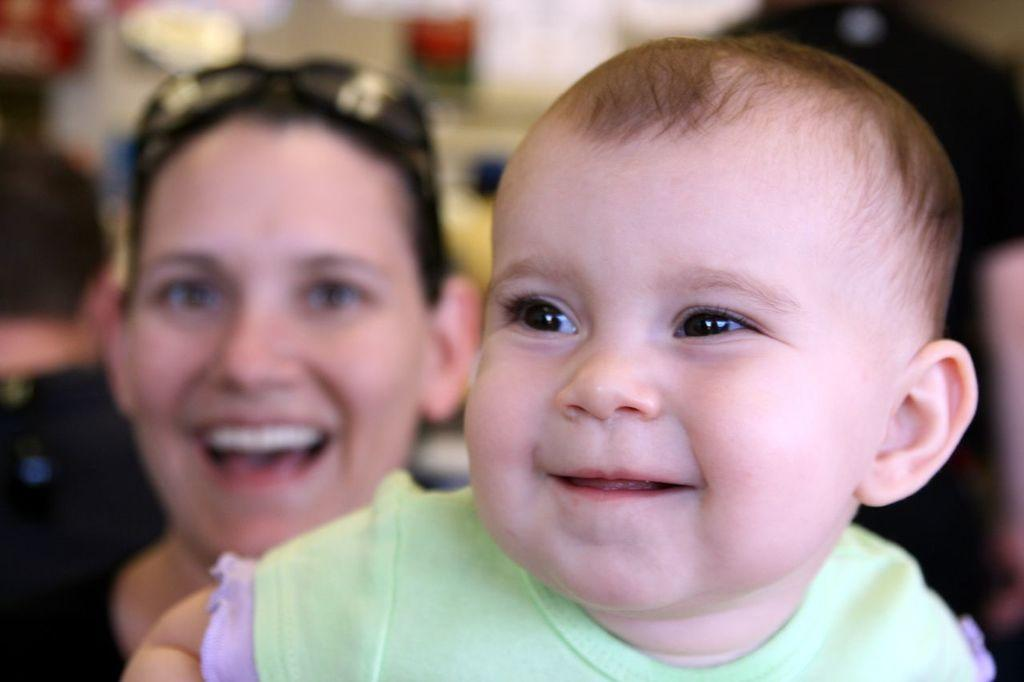Who is the main subject in the image? There is a baby in the image. What is the baby doing in the image? The baby is looking and smiling at someone. Can you describe the woman in the background of the image? The woman is smiling. What type of cent can be seen in the image? There is no cent present in the image. How many beams are supporting the coach in the image? There is no coach or beams present in the image. 